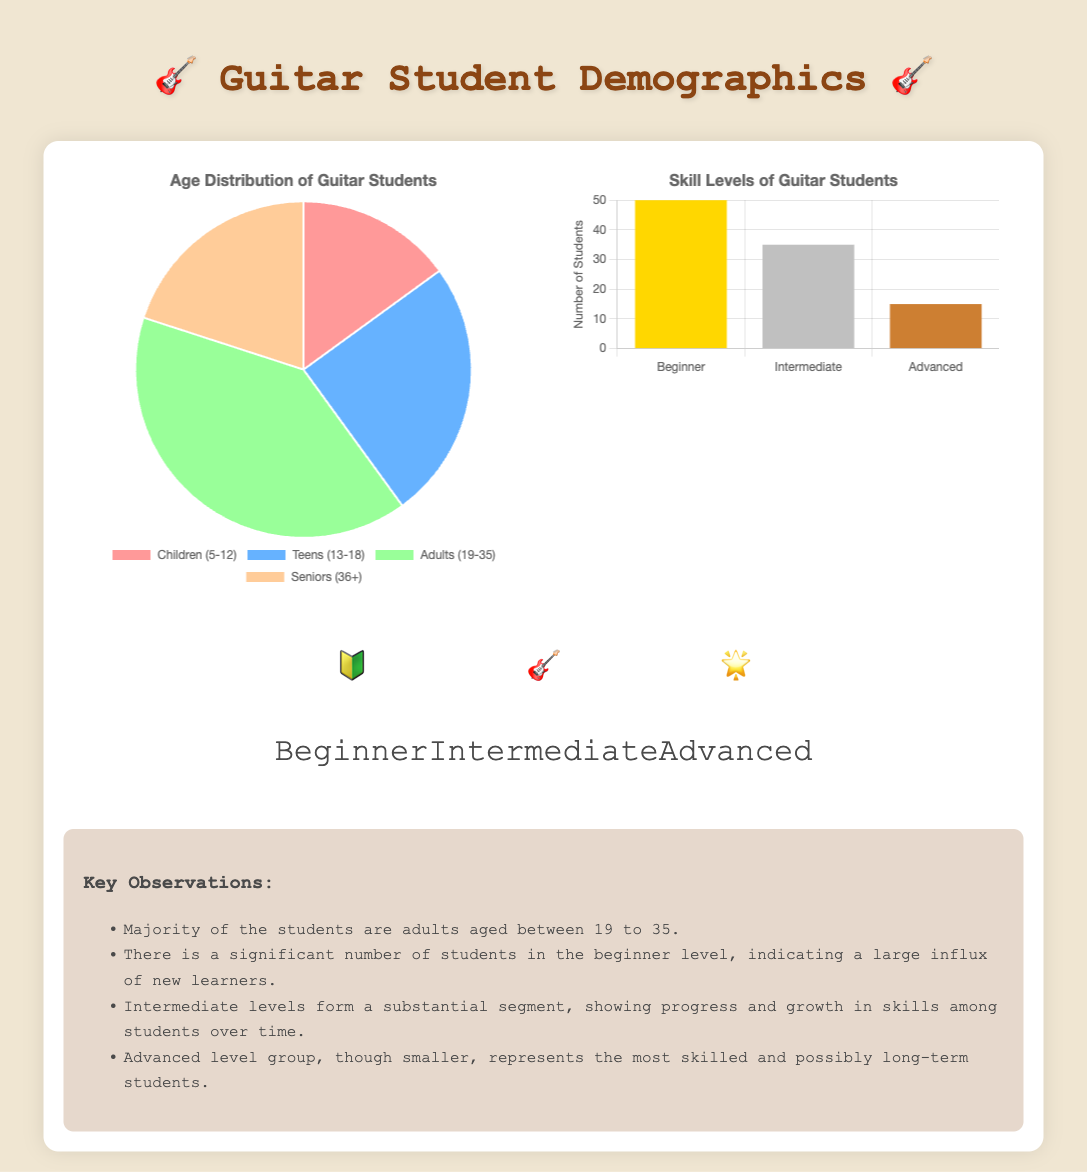what percentage of students are aged 19 to 35? The age distribution pie chart shows that 40% of the students are in the Adults (19-35) category.
Answer: 40% how many students are at the beginner level? The skill levels bar chart indicates there are 50 students classified as Beginners.
Answer: 50 what is the total number of students in the pie chart? By adding the values from the age distribution, there are a total of 100 students (15 from Children + 25 from Teens + 40 from Adults + 20 from Seniors).
Answer: 100 which age group has the lowest representation? By analyzing the age distribution, the Children (5-12) age group has the lowest number of students at 15.
Answer: Children (5-12) how does the number of Intermediate students compare to Advanced students? The bar chart shows there are 35 Intermediate students and 15 Advanced students, indicating that there are more Intermediate students.
Answer: More Intermediate students 